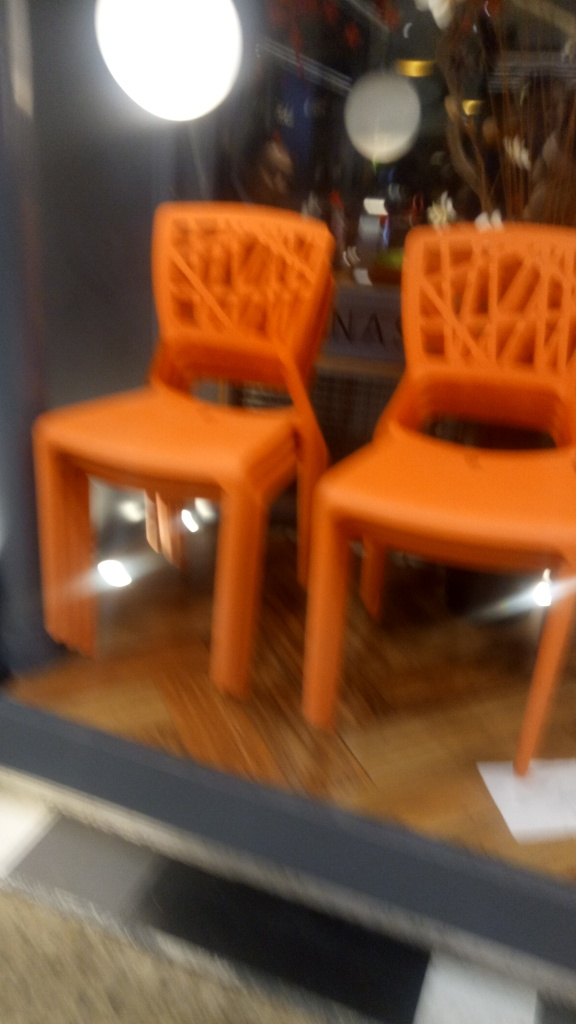What design style do the chairs in the image represent? The chairs have a modern design with a geometric pattern that seems to be inspired by contemporary aesthetics, utilizing clean lines and a monochromatic color scheme. 